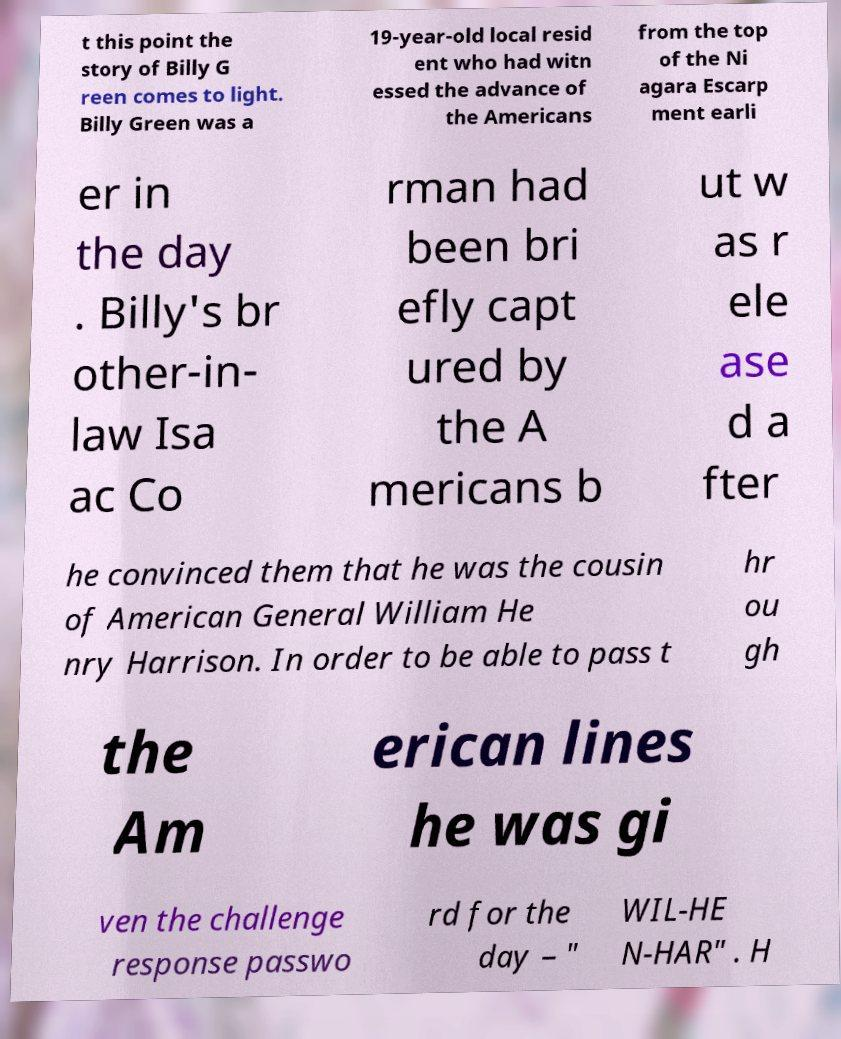I need the written content from this picture converted into text. Can you do that? t this point the story of Billy G reen comes to light. Billy Green was a 19-year-old local resid ent who had witn essed the advance of the Americans from the top of the Ni agara Escarp ment earli er in the day . Billy's br other-in- law Isa ac Co rman had been bri efly capt ured by the A mericans b ut w as r ele ase d a fter he convinced them that he was the cousin of American General William He nry Harrison. In order to be able to pass t hr ou gh the Am erican lines he was gi ven the challenge response passwo rd for the day – " WIL-HE N-HAR" . H 